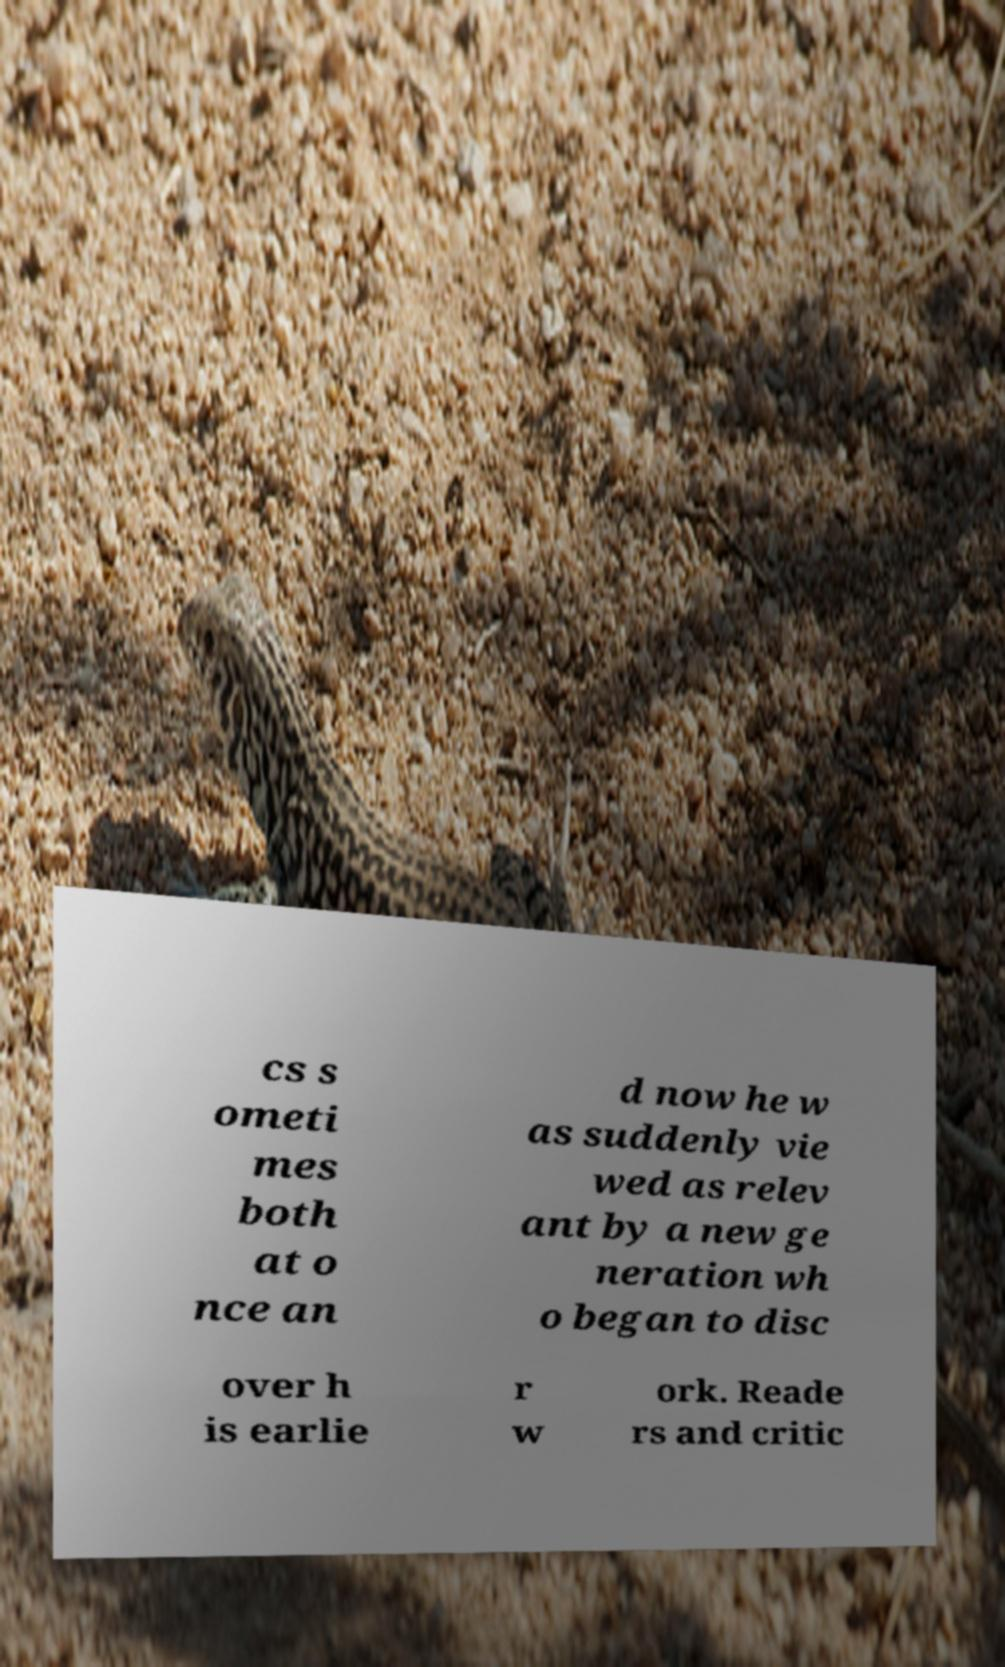Could you extract and type out the text from this image? cs s ometi mes both at o nce an d now he w as suddenly vie wed as relev ant by a new ge neration wh o began to disc over h is earlie r w ork. Reade rs and critic 